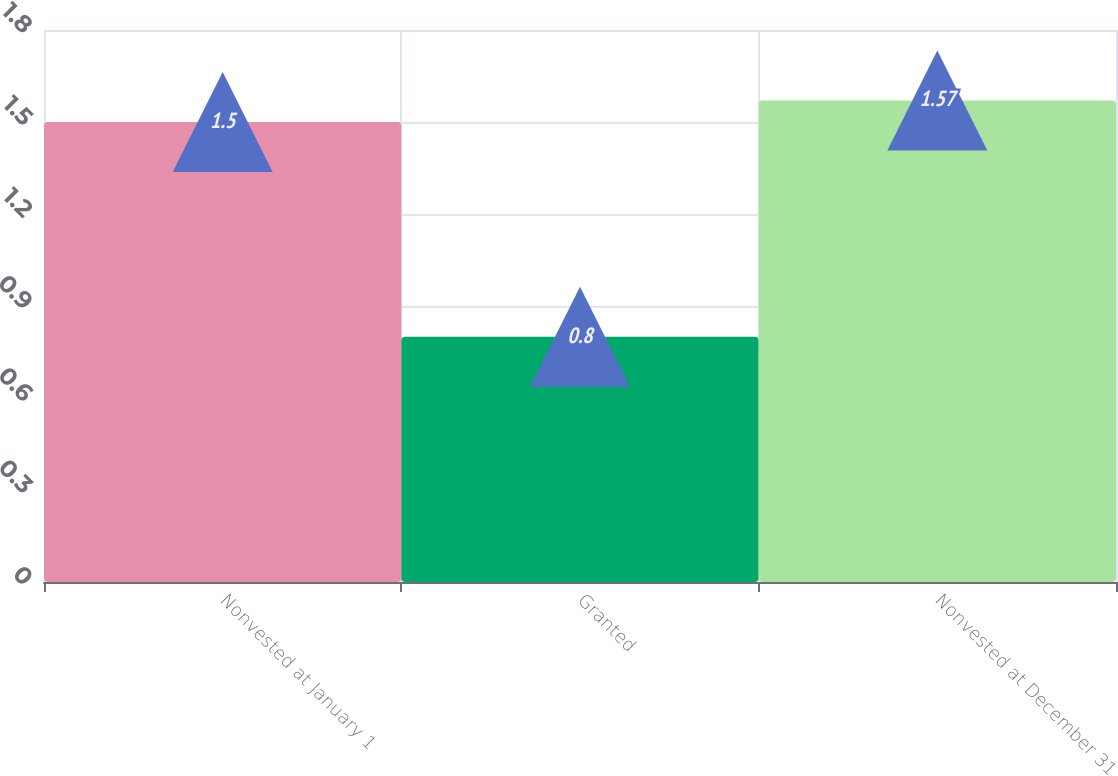Convert chart. <chart><loc_0><loc_0><loc_500><loc_500><bar_chart><fcel>Nonvested at January 1<fcel>Granted<fcel>Nonvested at December 31<nl><fcel>1.5<fcel>0.8<fcel>1.57<nl></chart> 